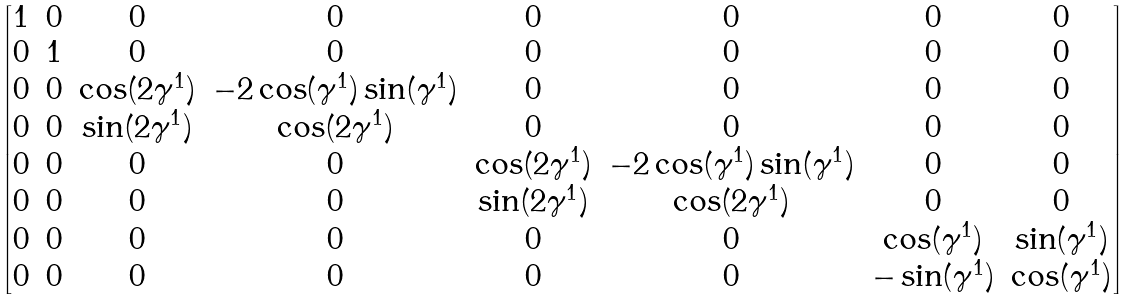Convert formula to latex. <formula><loc_0><loc_0><loc_500><loc_500>\begin{bmatrix} 1 & 0 & 0 & 0 & 0 & 0 & 0 & 0 \\ 0 & 1 & 0 & 0 & 0 & 0 & 0 & 0 \\ 0 & 0 & \cos ( 2 \gamma ^ { 1 } ) & - 2 \cos ( \gamma ^ { 1 } ) \sin ( \gamma ^ { 1 } ) & 0 & 0 & 0 & 0 \\ 0 & 0 & \sin ( 2 \gamma ^ { 1 } ) & \cos ( 2 \gamma ^ { 1 } ) & 0 & 0 & 0 & 0 \\ 0 & 0 & 0 & 0 & \cos ( 2 \gamma ^ { 1 } ) & - 2 \cos ( \gamma ^ { 1 } ) \sin ( \gamma ^ { 1 } ) & 0 & 0 \\ 0 & 0 & 0 & 0 & \sin ( 2 \gamma ^ { 1 } ) & \cos ( 2 \gamma ^ { 1 } ) & 0 & 0 \\ 0 & 0 & 0 & 0 & 0 & 0 & \cos ( \gamma ^ { 1 } ) & \sin ( \gamma ^ { 1 } ) \\ 0 & 0 & 0 & 0 & 0 & 0 & - \sin ( \gamma ^ { 1 } ) & \cos ( \gamma ^ { 1 } ) \end{bmatrix}</formula> 